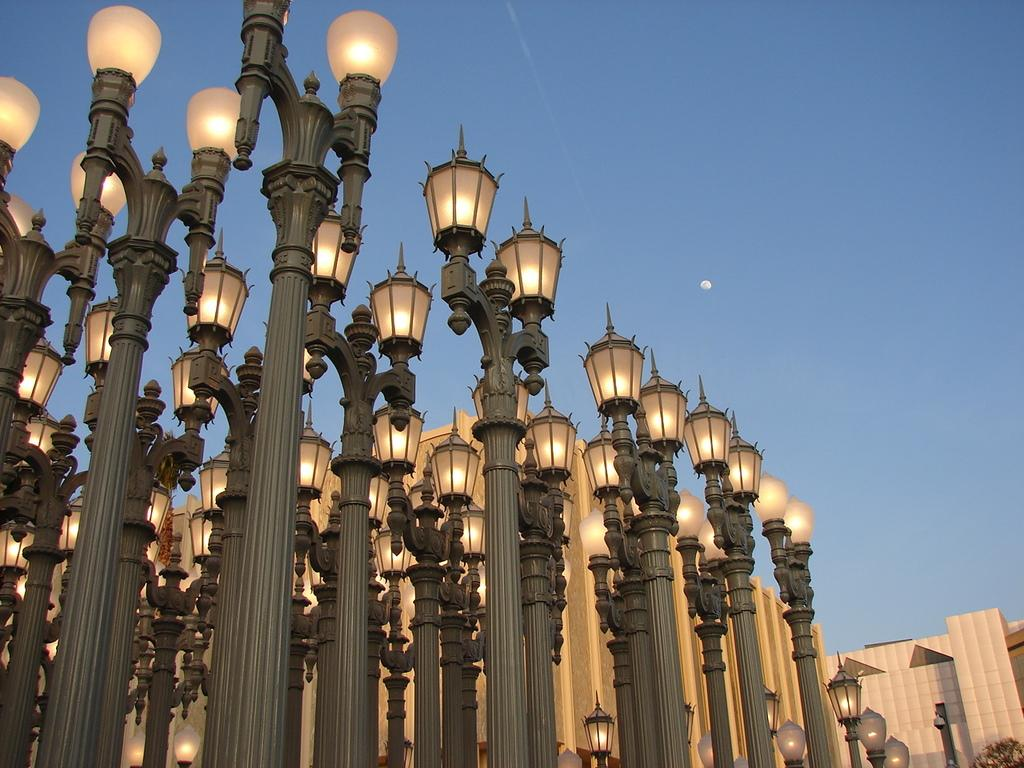What objects are present in large numbers in the image? There are many lamps in the image. What vertical structure can be seen in the image? There is a pole in the image. What type of architectural feature is visible in the image? There is a wall in the image. What part of the natural environment is visible in the image? The sky is visible in the image. What is the color of the sky in the image? The color of the sky is blue. What suggestion is being made by the rainstorm in the image? There is no rainstorm present in the image, so no suggestion can be made. 